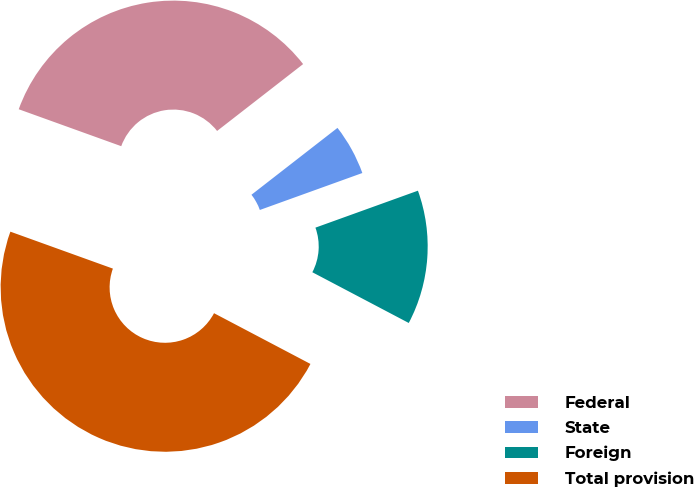<chart> <loc_0><loc_0><loc_500><loc_500><pie_chart><fcel>Federal<fcel>State<fcel>Foreign<fcel>Total provision<nl><fcel>33.98%<fcel>5.01%<fcel>13.22%<fcel>47.8%<nl></chart> 